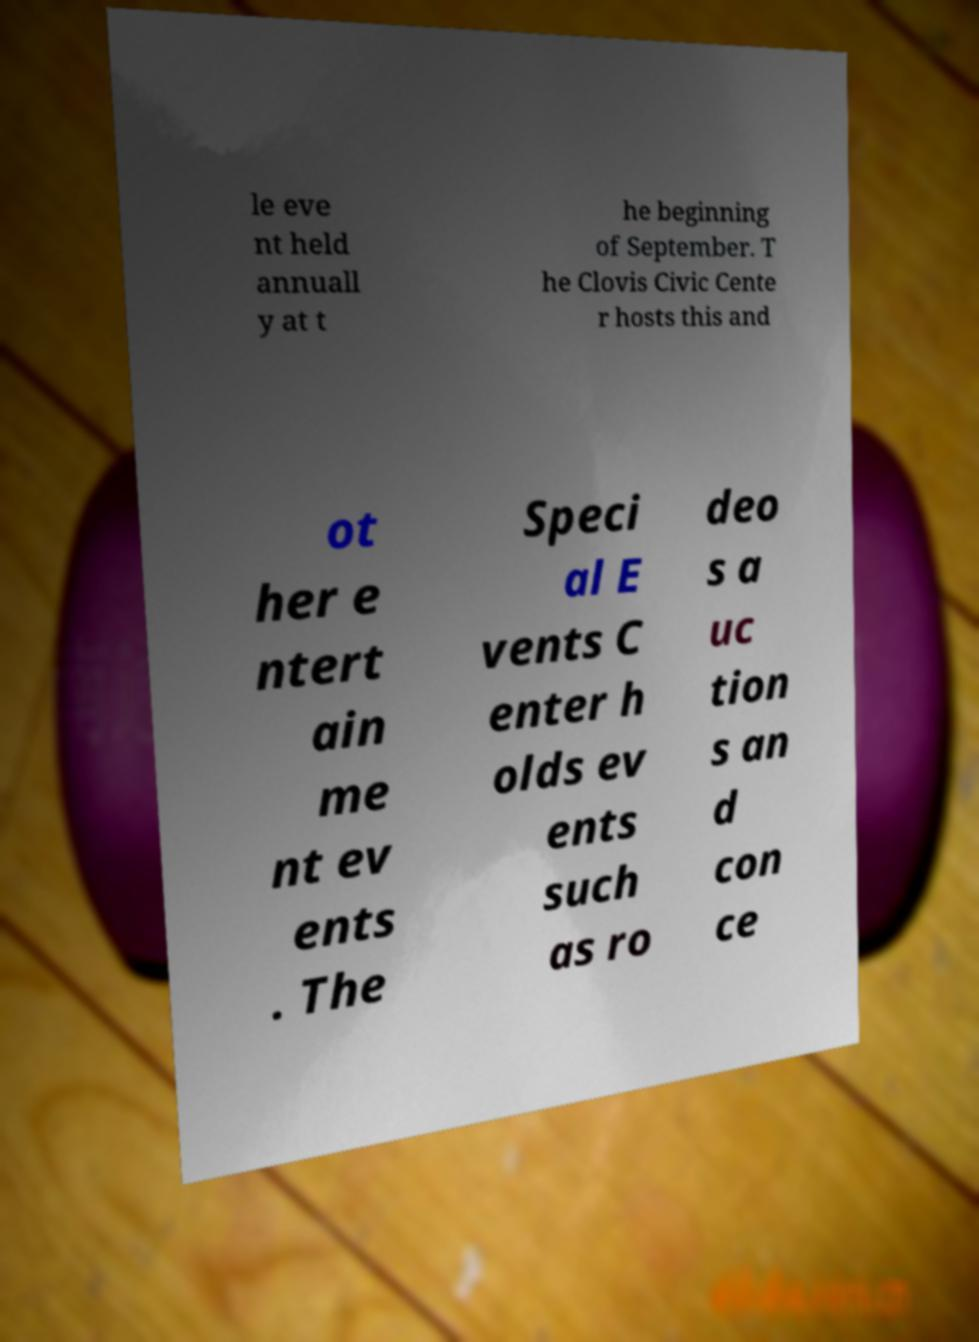Please identify and transcribe the text found in this image. le eve nt held annuall y at t he beginning of September. T he Clovis Civic Cente r hosts this and ot her e ntert ain me nt ev ents . The Speci al E vents C enter h olds ev ents such as ro deo s a uc tion s an d con ce 